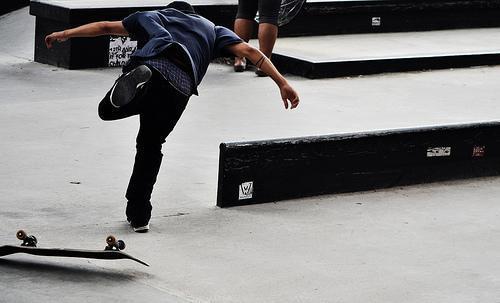How many wheels are on the skateboard?
Give a very brief answer. 4. 